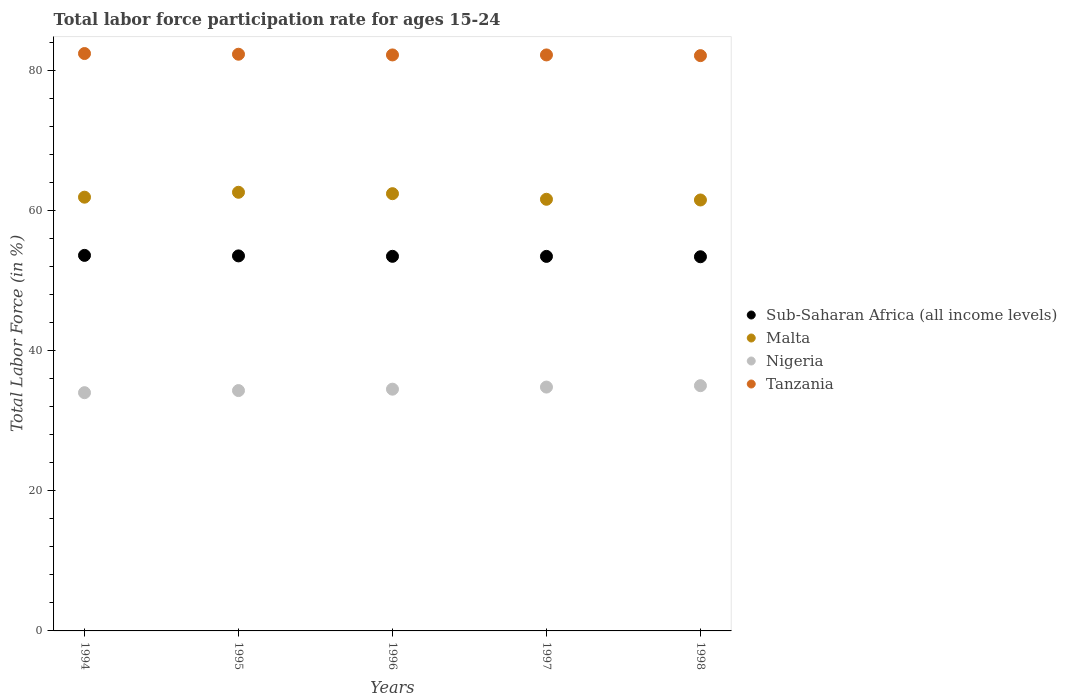What is the labor force participation rate in Tanzania in 1996?
Offer a very short reply. 82.2. Across all years, what is the maximum labor force participation rate in Tanzania?
Keep it short and to the point. 82.4. Across all years, what is the minimum labor force participation rate in Nigeria?
Make the answer very short. 34. In which year was the labor force participation rate in Tanzania minimum?
Provide a short and direct response. 1998. What is the total labor force participation rate in Sub-Saharan Africa (all income levels) in the graph?
Offer a very short reply. 267.42. What is the difference between the labor force participation rate in Sub-Saharan Africa (all income levels) in 1994 and the labor force participation rate in Nigeria in 1996?
Offer a terse response. 19.09. What is the average labor force participation rate in Malta per year?
Make the answer very short. 62. In the year 1996, what is the difference between the labor force participation rate in Tanzania and labor force participation rate in Malta?
Keep it short and to the point. 19.8. In how many years, is the labor force participation rate in Sub-Saharan Africa (all income levels) greater than 68 %?
Your response must be concise. 0. What is the ratio of the labor force participation rate in Malta in 1994 to that in 1997?
Provide a succinct answer. 1. Is the labor force participation rate in Tanzania in 1994 less than that in 1996?
Your answer should be compact. No. What is the difference between the highest and the second highest labor force participation rate in Malta?
Offer a terse response. 0.2. What is the difference between the highest and the lowest labor force participation rate in Sub-Saharan Africa (all income levels)?
Offer a terse response. 0.2. Is the sum of the labor force participation rate in Nigeria in 1994 and 1996 greater than the maximum labor force participation rate in Sub-Saharan Africa (all income levels) across all years?
Your answer should be very brief. Yes. Is it the case that in every year, the sum of the labor force participation rate in Tanzania and labor force participation rate in Sub-Saharan Africa (all income levels)  is greater than the sum of labor force participation rate in Nigeria and labor force participation rate in Malta?
Provide a succinct answer. Yes. Is it the case that in every year, the sum of the labor force participation rate in Nigeria and labor force participation rate in Tanzania  is greater than the labor force participation rate in Malta?
Make the answer very short. Yes. Does the labor force participation rate in Nigeria monotonically increase over the years?
Offer a very short reply. Yes. Is the labor force participation rate in Tanzania strictly greater than the labor force participation rate in Sub-Saharan Africa (all income levels) over the years?
Provide a succinct answer. Yes. What is the difference between two consecutive major ticks on the Y-axis?
Provide a short and direct response. 20. Where does the legend appear in the graph?
Offer a terse response. Center right. How are the legend labels stacked?
Your response must be concise. Vertical. What is the title of the graph?
Provide a short and direct response. Total labor force participation rate for ages 15-24. Does "Austria" appear as one of the legend labels in the graph?
Offer a terse response. No. What is the Total Labor Force (in %) in Sub-Saharan Africa (all income levels) in 1994?
Make the answer very short. 53.59. What is the Total Labor Force (in %) in Malta in 1994?
Provide a succinct answer. 61.9. What is the Total Labor Force (in %) of Tanzania in 1994?
Offer a very short reply. 82.4. What is the Total Labor Force (in %) of Sub-Saharan Africa (all income levels) in 1995?
Your response must be concise. 53.52. What is the Total Labor Force (in %) of Malta in 1995?
Offer a very short reply. 62.6. What is the Total Labor Force (in %) of Nigeria in 1995?
Offer a very short reply. 34.3. What is the Total Labor Force (in %) in Tanzania in 1995?
Keep it short and to the point. 82.3. What is the Total Labor Force (in %) in Sub-Saharan Africa (all income levels) in 1996?
Ensure brevity in your answer.  53.46. What is the Total Labor Force (in %) in Malta in 1996?
Your answer should be very brief. 62.4. What is the Total Labor Force (in %) in Nigeria in 1996?
Give a very brief answer. 34.5. What is the Total Labor Force (in %) of Tanzania in 1996?
Offer a very short reply. 82.2. What is the Total Labor Force (in %) in Sub-Saharan Africa (all income levels) in 1997?
Make the answer very short. 53.45. What is the Total Labor Force (in %) of Malta in 1997?
Make the answer very short. 61.6. What is the Total Labor Force (in %) of Nigeria in 1997?
Offer a terse response. 34.8. What is the Total Labor Force (in %) in Tanzania in 1997?
Your response must be concise. 82.2. What is the Total Labor Force (in %) in Sub-Saharan Africa (all income levels) in 1998?
Your response must be concise. 53.4. What is the Total Labor Force (in %) in Malta in 1998?
Give a very brief answer. 61.5. What is the Total Labor Force (in %) in Nigeria in 1998?
Offer a terse response. 35. What is the Total Labor Force (in %) in Tanzania in 1998?
Give a very brief answer. 82.1. Across all years, what is the maximum Total Labor Force (in %) in Sub-Saharan Africa (all income levels)?
Provide a succinct answer. 53.59. Across all years, what is the maximum Total Labor Force (in %) of Malta?
Give a very brief answer. 62.6. Across all years, what is the maximum Total Labor Force (in %) of Nigeria?
Give a very brief answer. 35. Across all years, what is the maximum Total Labor Force (in %) in Tanzania?
Offer a terse response. 82.4. Across all years, what is the minimum Total Labor Force (in %) in Sub-Saharan Africa (all income levels)?
Make the answer very short. 53.4. Across all years, what is the minimum Total Labor Force (in %) in Malta?
Provide a succinct answer. 61.5. Across all years, what is the minimum Total Labor Force (in %) of Tanzania?
Provide a short and direct response. 82.1. What is the total Total Labor Force (in %) in Sub-Saharan Africa (all income levels) in the graph?
Your answer should be very brief. 267.42. What is the total Total Labor Force (in %) in Malta in the graph?
Offer a very short reply. 310. What is the total Total Labor Force (in %) of Nigeria in the graph?
Give a very brief answer. 172.6. What is the total Total Labor Force (in %) of Tanzania in the graph?
Make the answer very short. 411.2. What is the difference between the Total Labor Force (in %) of Sub-Saharan Africa (all income levels) in 1994 and that in 1995?
Provide a succinct answer. 0.07. What is the difference between the Total Labor Force (in %) in Malta in 1994 and that in 1995?
Your answer should be compact. -0.7. What is the difference between the Total Labor Force (in %) of Nigeria in 1994 and that in 1995?
Provide a short and direct response. -0.3. What is the difference between the Total Labor Force (in %) in Tanzania in 1994 and that in 1995?
Make the answer very short. 0.1. What is the difference between the Total Labor Force (in %) in Sub-Saharan Africa (all income levels) in 1994 and that in 1996?
Your answer should be compact. 0.13. What is the difference between the Total Labor Force (in %) of Nigeria in 1994 and that in 1996?
Provide a succinct answer. -0.5. What is the difference between the Total Labor Force (in %) in Tanzania in 1994 and that in 1996?
Give a very brief answer. 0.2. What is the difference between the Total Labor Force (in %) of Sub-Saharan Africa (all income levels) in 1994 and that in 1997?
Ensure brevity in your answer.  0.14. What is the difference between the Total Labor Force (in %) of Tanzania in 1994 and that in 1997?
Your response must be concise. 0.2. What is the difference between the Total Labor Force (in %) in Sub-Saharan Africa (all income levels) in 1994 and that in 1998?
Provide a succinct answer. 0.2. What is the difference between the Total Labor Force (in %) of Tanzania in 1994 and that in 1998?
Your answer should be compact. 0.3. What is the difference between the Total Labor Force (in %) in Sub-Saharan Africa (all income levels) in 1995 and that in 1996?
Your answer should be compact. 0.06. What is the difference between the Total Labor Force (in %) of Tanzania in 1995 and that in 1996?
Your answer should be compact. 0.1. What is the difference between the Total Labor Force (in %) in Sub-Saharan Africa (all income levels) in 1995 and that in 1997?
Provide a short and direct response. 0.07. What is the difference between the Total Labor Force (in %) of Malta in 1995 and that in 1997?
Provide a short and direct response. 1. What is the difference between the Total Labor Force (in %) in Nigeria in 1995 and that in 1997?
Your answer should be compact. -0.5. What is the difference between the Total Labor Force (in %) of Sub-Saharan Africa (all income levels) in 1995 and that in 1998?
Provide a short and direct response. 0.12. What is the difference between the Total Labor Force (in %) of Nigeria in 1995 and that in 1998?
Provide a short and direct response. -0.7. What is the difference between the Total Labor Force (in %) in Tanzania in 1995 and that in 1998?
Your answer should be very brief. 0.2. What is the difference between the Total Labor Force (in %) in Sub-Saharan Africa (all income levels) in 1996 and that in 1997?
Your response must be concise. 0.01. What is the difference between the Total Labor Force (in %) in Malta in 1996 and that in 1997?
Make the answer very short. 0.8. What is the difference between the Total Labor Force (in %) in Sub-Saharan Africa (all income levels) in 1996 and that in 1998?
Ensure brevity in your answer.  0.06. What is the difference between the Total Labor Force (in %) of Tanzania in 1996 and that in 1998?
Keep it short and to the point. 0.1. What is the difference between the Total Labor Force (in %) of Sub-Saharan Africa (all income levels) in 1997 and that in 1998?
Provide a short and direct response. 0.05. What is the difference between the Total Labor Force (in %) of Malta in 1997 and that in 1998?
Provide a short and direct response. 0.1. What is the difference between the Total Labor Force (in %) in Nigeria in 1997 and that in 1998?
Offer a very short reply. -0.2. What is the difference between the Total Labor Force (in %) of Tanzania in 1997 and that in 1998?
Provide a short and direct response. 0.1. What is the difference between the Total Labor Force (in %) in Sub-Saharan Africa (all income levels) in 1994 and the Total Labor Force (in %) in Malta in 1995?
Offer a very short reply. -9.01. What is the difference between the Total Labor Force (in %) of Sub-Saharan Africa (all income levels) in 1994 and the Total Labor Force (in %) of Nigeria in 1995?
Your answer should be compact. 19.29. What is the difference between the Total Labor Force (in %) in Sub-Saharan Africa (all income levels) in 1994 and the Total Labor Force (in %) in Tanzania in 1995?
Offer a terse response. -28.71. What is the difference between the Total Labor Force (in %) of Malta in 1994 and the Total Labor Force (in %) of Nigeria in 1995?
Your answer should be compact. 27.6. What is the difference between the Total Labor Force (in %) in Malta in 1994 and the Total Labor Force (in %) in Tanzania in 1995?
Your answer should be compact. -20.4. What is the difference between the Total Labor Force (in %) in Nigeria in 1994 and the Total Labor Force (in %) in Tanzania in 1995?
Your answer should be very brief. -48.3. What is the difference between the Total Labor Force (in %) of Sub-Saharan Africa (all income levels) in 1994 and the Total Labor Force (in %) of Malta in 1996?
Offer a very short reply. -8.81. What is the difference between the Total Labor Force (in %) in Sub-Saharan Africa (all income levels) in 1994 and the Total Labor Force (in %) in Nigeria in 1996?
Your response must be concise. 19.09. What is the difference between the Total Labor Force (in %) in Sub-Saharan Africa (all income levels) in 1994 and the Total Labor Force (in %) in Tanzania in 1996?
Your answer should be very brief. -28.61. What is the difference between the Total Labor Force (in %) of Malta in 1994 and the Total Labor Force (in %) of Nigeria in 1996?
Provide a short and direct response. 27.4. What is the difference between the Total Labor Force (in %) in Malta in 1994 and the Total Labor Force (in %) in Tanzania in 1996?
Provide a short and direct response. -20.3. What is the difference between the Total Labor Force (in %) of Nigeria in 1994 and the Total Labor Force (in %) of Tanzania in 1996?
Provide a succinct answer. -48.2. What is the difference between the Total Labor Force (in %) in Sub-Saharan Africa (all income levels) in 1994 and the Total Labor Force (in %) in Malta in 1997?
Offer a terse response. -8.01. What is the difference between the Total Labor Force (in %) of Sub-Saharan Africa (all income levels) in 1994 and the Total Labor Force (in %) of Nigeria in 1997?
Keep it short and to the point. 18.79. What is the difference between the Total Labor Force (in %) in Sub-Saharan Africa (all income levels) in 1994 and the Total Labor Force (in %) in Tanzania in 1997?
Offer a very short reply. -28.61. What is the difference between the Total Labor Force (in %) of Malta in 1994 and the Total Labor Force (in %) of Nigeria in 1997?
Ensure brevity in your answer.  27.1. What is the difference between the Total Labor Force (in %) of Malta in 1994 and the Total Labor Force (in %) of Tanzania in 1997?
Offer a very short reply. -20.3. What is the difference between the Total Labor Force (in %) of Nigeria in 1994 and the Total Labor Force (in %) of Tanzania in 1997?
Ensure brevity in your answer.  -48.2. What is the difference between the Total Labor Force (in %) of Sub-Saharan Africa (all income levels) in 1994 and the Total Labor Force (in %) of Malta in 1998?
Ensure brevity in your answer.  -7.91. What is the difference between the Total Labor Force (in %) in Sub-Saharan Africa (all income levels) in 1994 and the Total Labor Force (in %) in Nigeria in 1998?
Your answer should be very brief. 18.59. What is the difference between the Total Labor Force (in %) in Sub-Saharan Africa (all income levels) in 1994 and the Total Labor Force (in %) in Tanzania in 1998?
Your answer should be very brief. -28.51. What is the difference between the Total Labor Force (in %) in Malta in 1994 and the Total Labor Force (in %) in Nigeria in 1998?
Offer a terse response. 26.9. What is the difference between the Total Labor Force (in %) of Malta in 1994 and the Total Labor Force (in %) of Tanzania in 1998?
Offer a terse response. -20.2. What is the difference between the Total Labor Force (in %) in Nigeria in 1994 and the Total Labor Force (in %) in Tanzania in 1998?
Offer a terse response. -48.1. What is the difference between the Total Labor Force (in %) in Sub-Saharan Africa (all income levels) in 1995 and the Total Labor Force (in %) in Malta in 1996?
Your response must be concise. -8.88. What is the difference between the Total Labor Force (in %) of Sub-Saharan Africa (all income levels) in 1995 and the Total Labor Force (in %) of Nigeria in 1996?
Give a very brief answer. 19.02. What is the difference between the Total Labor Force (in %) in Sub-Saharan Africa (all income levels) in 1995 and the Total Labor Force (in %) in Tanzania in 1996?
Offer a terse response. -28.68. What is the difference between the Total Labor Force (in %) in Malta in 1995 and the Total Labor Force (in %) in Nigeria in 1996?
Provide a succinct answer. 28.1. What is the difference between the Total Labor Force (in %) of Malta in 1995 and the Total Labor Force (in %) of Tanzania in 1996?
Offer a terse response. -19.6. What is the difference between the Total Labor Force (in %) in Nigeria in 1995 and the Total Labor Force (in %) in Tanzania in 1996?
Your answer should be compact. -47.9. What is the difference between the Total Labor Force (in %) in Sub-Saharan Africa (all income levels) in 1995 and the Total Labor Force (in %) in Malta in 1997?
Your answer should be compact. -8.08. What is the difference between the Total Labor Force (in %) in Sub-Saharan Africa (all income levels) in 1995 and the Total Labor Force (in %) in Nigeria in 1997?
Your answer should be compact. 18.72. What is the difference between the Total Labor Force (in %) in Sub-Saharan Africa (all income levels) in 1995 and the Total Labor Force (in %) in Tanzania in 1997?
Provide a succinct answer. -28.68. What is the difference between the Total Labor Force (in %) of Malta in 1995 and the Total Labor Force (in %) of Nigeria in 1997?
Make the answer very short. 27.8. What is the difference between the Total Labor Force (in %) of Malta in 1995 and the Total Labor Force (in %) of Tanzania in 1997?
Offer a terse response. -19.6. What is the difference between the Total Labor Force (in %) of Nigeria in 1995 and the Total Labor Force (in %) of Tanzania in 1997?
Make the answer very short. -47.9. What is the difference between the Total Labor Force (in %) of Sub-Saharan Africa (all income levels) in 1995 and the Total Labor Force (in %) of Malta in 1998?
Provide a short and direct response. -7.98. What is the difference between the Total Labor Force (in %) in Sub-Saharan Africa (all income levels) in 1995 and the Total Labor Force (in %) in Nigeria in 1998?
Offer a very short reply. 18.52. What is the difference between the Total Labor Force (in %) in Sub-Saharan Africa (all income levels) in 1995 and the Total Labor Force (in %) in Tanzania in 1998?
Give a very brief answer. -28.58. What is the difference between the Total Labor Force (in %) in Malta in 1995 and the Total Labor Force (in %) in Nigeria in 1998?
Keep it short and to the point. 27.6. What is the difference between the Total Labor Force (in %) in Malta in 1995 and the Total Labor Force (in %) in Tanzania in 1998?
Give a very brief answer. -19.5. What is the difference between the Total Labor Force (in %) of Nigeria in 1995 and the Total Labor Force (in %) of Tanzania in 1998?
Your response must be concise. -47.8. What is the difference between the Total Labor Force (in %) in Sub-Saharan Africa (all income levels) in 1996 and the Total Labor Force (in %) in Malta in 1997?
Your answer should be compact. -8.14. What is the difference between the Total Labor Force (in %) in Sub-Saharan Africa (all income levels) in 1996 and the Total Labor Force (in %) in Nigeria in 1997?
Your answer should be compact. 18.66. What is the difference between the Total Labor Force (in %) in Sub-Saharan Africa (all income levels) in 1996 and the Total Labor Force (in %) in Tanzania in 1997?
Your answer should be compact. -28.74. What is the difference between the Total Labor Force (in %) in Malta in 1996 and the Total Labor Force (in %) in Nigeria in 1997?
Ensure brevity in your answer.  27.6. What is the difference between the Total Labor Force (in %) of Malta in 1996 and the Total Labor Force (in %) of Tanzania in 1997?
Offer a very short reply. -19.8. What is the difference between the Total Labor Force (in %) in Nigeria in 1996 and the Total Labor Force (in %) in Tanzania in 1997?
Your answer should be compact. -47.7. What is the difference between the Total Labor Force (in %) of Sub-Saharan Africa (all income levels) in 1996 and the Total Labor Force (in %) of Malta in 1998?
Make the answer very short. -8.04. What is the difference between the Total Labor Force (in %) of Sub-Saharan Africa (all income levels) in 1996 and the Total Labor Force (in %) of Nigeria in 1998?
Your response must be concise. 18.46. What is the difference between the Total Labor Force (in %) of Sub-Saharan Africa (all income levels) in 1996 and the Total Labor Force (in %) of Tanzania in 1998?
Offer a very short reply. -28.64. What is the difference between the Total Labor Force (in %) in Malta in 1996 and the Total Labor Force (in %) in Nigeria in 1998?
Ensure brevity in your answer.  27.4. What is the difference between the Total Labor Force (in %) in Malta in 1996 and the Total Labor Force (in %) in Tanzania in 1998?
Keep it short and to the point. -19.7. What is the difference between the Total Labor Force (in %) of Nigeria in 1996 and the Total Labor Force (in %) of Tanzania in 1998?
Make the answer very short. -47.6. What is the difference between the Total Labor Force (in %) of Sub-Saharan Africa (all income levels) in 1997 and the Total Labor Force (in %) of Malta in 1998?
Keep it short and to the point. -8.05. What is the difference between the Total Labor Force (in %) of Sub-Saharan Africa (all income levels) in 1997 and the Total Labor Force (in %) of Nigeria in 1998?
Your answer should be compact. 18.45. What is the difference between the Total Labor Force (in %) of Sub-Saharan Africa (all income levels) in 1997 and the Total Labor Force (in %) of Tanzania in 1998?
Make the answer very short. -28.65. What is the difference between the Total Labor Force (in %) in Malta in 1997 and the Total Labor Force (in %) in Nigeria in 1998?
Your answer should be very brief. 26.6. What is the difference between the Total Labor Force (in %) in Malta in 1997 and the Total Labor Force (in %) in Tanzania in 1998?
Offer a terse response. -20.5. What is the difference between the Total Labor Force (in %) in Nigeria in 1997 and the Total Labor Force (in %) in Tanzania in 1998?
Provide a short and direct response. -47.3. What is the average Total Labor Force (in %) of Sub-Saharan Africa (all income levels) per year?
Offer a very short reply. 53.48. What is the average Total Labor Force (in %) of Nigeria per year?
Make the answer very short. 34.52. What is the average Total Labor Force (in %) in Tanzania per year?
Ensure brevity in your answer.  82.24. In the year 1994, what is the difference between the Total Labor Force (in %) in Sub-Saharan Africa (all income levels) and Total Labor Force (in %) in Malta?
Keep it short and to the point. -8.31. In the year 1994, what is the difference between the Total Labor Force (in %) in Sub-Saharan Africa (all income levels) and Total Labor Force (in %) in Nigeria?
Keep it short and to the point. 19.59. In the year 1994, what is the difference between the Total Labor Force (in %) of Sub-Saharan Africa (all income levels) and Total Labor Force (in %) of Tanzania?
Provide a succinct answer. -28.81. In the year 1994, what is the difference between the Total Labor Force (in %) in Malta and Total Labor Force (in %) in Nigeria?
Give a very brief answer. 27.9. In the year 1994, what is the difference between the Total Labor Force (in %) in Malta and Total Labor Force (in %) in Tanzania?
Offer a terse response. -20.5. In the year 1994, what is the difference between the Total Labor Force (in %) of Nigeria and Total Labor Force (in %) of Tanzania?
Keep it short and to the point. -48.4. In the year 1995, what is the difference between the Total Labor Force (in %) of Sub-Saharan Africa (all income levels) and Total Labor Force (in %) of Malta?
Provide a succinct answer. -9.08. In the year 1995, what is the difference between the Total Labor Force (in %) of Sub-Saharan Africa (all income levels) and Total Labor Force (in %) of Nigeria?
Ensure brevity in your answer.  19.22. In the year 1995, what is the difference between the Total Labor Force (in %) of Sub-Saharan Africa (all income levels) and Total Labor Force (in %) of Tanzania?
Give a very brief answer. -28.78. In the year 1995, what is the difference between the Total Labor Force (in %) of Malta and Total Labor Force (in %) of Nigeria?
Your response must be concise. 28.3. In the year 1995, what is the difference between the Total Labor Force (in %) of Malta and Total Labor Force (in %) of Tanzania?
Provide a short and direct response. -19.7. In the year 1995, what is the difference between the Total Labor Force (in %) in Nigeria and Total Labor Force (in %) in Tanzania?
Ensure brevity in your answer.  -48. In the year 1996, what is the difference between the Total Labor Force (in %) of Sub-Saharan Africa (all income levels) and Total Labor Force (in %) of Malta?
Ensure brevity in your answer.  -8.94. In the year 1996, what is the difference between the Total Labor Force (in %) in Sub-Saharan Africa (all income levels) and Total Labor Force (in %) in Nigeria?
Keep it short and to the point. 18.96. In the year 1996, what is the difference between the Total Labor Force (in %) of Sub-Saharan Africa (all income levels) and Total Labor Force (in %) of Tanzania?
Offer a terse response. -28.74. In the year 1996, what is the difference between the Total Labor Force (in %) of Malta and Total Labor Force (in %) of Nigeria?
Offer a terse response. 27.9. In the year 1996, what is the difference between the Total Labor Force (in %) of Malta and Total Labor Force (in %) of Tanzania?
Ensure brevity in your answer.  -19.8. In the year 1996, what is the difference between the Total Labor Force (in %) of Nigeria and Total Labor Force (in %) of Tanzania?
Make the answer very short. -47.7. In the year 1997, what is the difference between the Total Labor Force (in %) in Sub-Saharan Africa (all income levels) and Total Labor Force (in %) in Malta?
Provide a succinct answer. -8.15. In the year 1997, what is the difference between the Total Labor Force (in %) of Sub-Saharan Africa (all income levels) and Total Labor Force (in %) of Nigeria?
Offer a very short reply. 18.65. In the year 1997, what is the difference between the Total Labor Force (in %) of Sub-Saharan Africa (all income levels) and Total Labor Force (in %) of Tanzania?
Ensure brevity in your answer.  -28.75. In the year 1997, what is the difference between the Total Labor Force (in %) of Malta and Total Labor Force (in %) of Nigeria?
Your answer should be very brief. 26.8. In the year 1997, what is the difference between the Total Labor Force (in %) of Malta and Total Labor Force (in %) of Tanzania?
Make the answer very short. -20.6. In the year 1997, what is the difference between the Total Labor Force (in %) in Nigeria and Total Labor Force (in %) in Tanzania?
Provide a short and direct response. -47.4. In the year 1998, what is the difference between the Total Labor Force (in %) in Sub-Saharan Africa (all income levels) and Total Labor Force (in %) in Malta?
Offer a very short reply. -8.1. In the year 1998, what is the difference between the Total Labor Force (in %) in Sub-Saharan Africa (all income levels) and Total Labor Force (in %) in Nigeria?
Your answer should be compact. 18.4. In the year 1998, what is the difference between the Total Labor Force (in %) of Sub-Saharan Africa (all income levels) and Total Labor Force (in %) of Tanzania?
Offer a terse response. -28.7. In the year 1998, what is the difference between the Total Labor Force (in %) in Malta and Total Labor Force (in %) in Nigeria?
Your response must be concise. 26.5. In the year 1998, what is the difference between the Total Labor Force (in %) of Malta and Total Labor Force (in %) of Tanzania?
Offer a very short reply. -20.6. In the year 1998, what is the difference between the Total Labor Force (in %) of Nigeria and Total Labor Force (in %) of Tanzania?
Keep it short and to the point. -47.1. What is the ratio of the Total Labor Force (in %) in Malta in 1994 to that in 1995?
Your answer should be compact. 0.99. What is the ratio of the Total Labor Force (in %) of Nigeria in 1994 to that in 1995?
Give a very brief answer. 0.99. What is the ratio of the Total Labor Force (in %) of Nigeria in 1994 to that in 1996?
Make the answer very short. 0.99. What is the ratio of the Total Labor Force (in %) of Tanzania in 1994 to that in 1996?
Provide a succinct answer. 1. What is the ratio of the Total Labor Force (in %) of Sub-Saharan Africa (all income levels) in 1994 to that in 1997?
Make the answer very short. 1. What is the ratio of the Total Labor Force (in %) in Malta in 1994 to that in 1997?
Your response must be concise. 1. What is the ratio of the Total Labor Force (in %) in Tanzania in 1994 to that in 1997?
Your answer should be very brief. 1. What is the ratio of the Total Labor Force (in %) in Sub-Saharan Africa (all income levels) in 1994 to that in 1998?
Ensure brevity in your answer.  1. What is the ratio of the Total Labor Force (in %) in Nigeria in 1994 to that in 1998?
Provide a short and direct response. 0.97. What is the ratio of the Total Labor Force (in %) in Tanzania in 1994 to that in 1998?
Give a very brief answer. 1. What is the ratio of the Total Labor Force (in %) in Sub-Saharan Africa (all income levels) in 1995 to that in 1996?
Make the answer very short. 1. What is the ratio of the Total Labor Force (in %) of Nigeria in 1995 to that in 1996?
Keep it short and to the point. 0.99. What is the ratio of the Total Labor Force (in %) of Malta in 1995 to that in 1997?
Your answer should be compact. 1.02. What is the ratio of the Total Labor Force (in %) of Nigeria in 1995 to that in 1997?
Provide a short and direct response. 0.99. What is the ratio of the Total Labor Force (in %) of Tanzania in 1995 to that in 1997?
Keep it short and to the point. 1. What is the ratio of the Total Labor Force (in %) in Malta in 1995 to that in 1998?
Ensure brevity in your answer.  1.02. What is the ratio of the Total Labor Force (in %) of Nigeria in 1995 to that in 1998?
Provide a succinct answer. 0.98. What is the ratio of the Total Labor Force (in %) in Nigeria in 1996 to that in 1997?
Your response must be concise. 0.99. What is the ratio of the Total Labor Force (in %) in Tanzania in 1996 to that in 1997?
Your response must be concise. 1. What is the ratio of the Total Labor Force (in %) of Sub-Saharan Africa (all income levels) in 1996 to that in 1998?
Make the answer very short. 1. What is the ratio of the Total Labor Force (in %) in Malta in 1996 to that in 1998?
Provide a short and direct response. 1.01. What is the ratio of the Total Labor Force (in %) of Nigeria in 1996 to that in 1998?
Your response must be concise. 0.99. What is the ratio of the Total Labor Force (in %) in Tanzania in 1996 to that in 1998?
Make the answer very short. 1. What is the ratio of the Total Labor Force (in %) in Malta in 1997 to that in 1998?
Your response must be concise. 1. What is the difference between the highest and the second highest Total Labor Force (in %) in Sub-Saharan Africa (all income levels)?
Your response must be concise. 0.07. What is the difference between the highest and the second highest Total Labor Force (in %) of Nigeria?
Offer a terse response. 0.2. What is the difference between the highest and the second highest Total Labor Force (in %) in Tanzania?
Your answer should be compact. 0.1. What is the difference between the highest and the lowest Total Labor Force (in %) in Sub-Saharan Africa (all income levels)?
Your response must be concise. 0.2. What is the difference between the highest and the lowest Total Labor Force (in %) in Malta?
Make the answer very short. 1.1. 